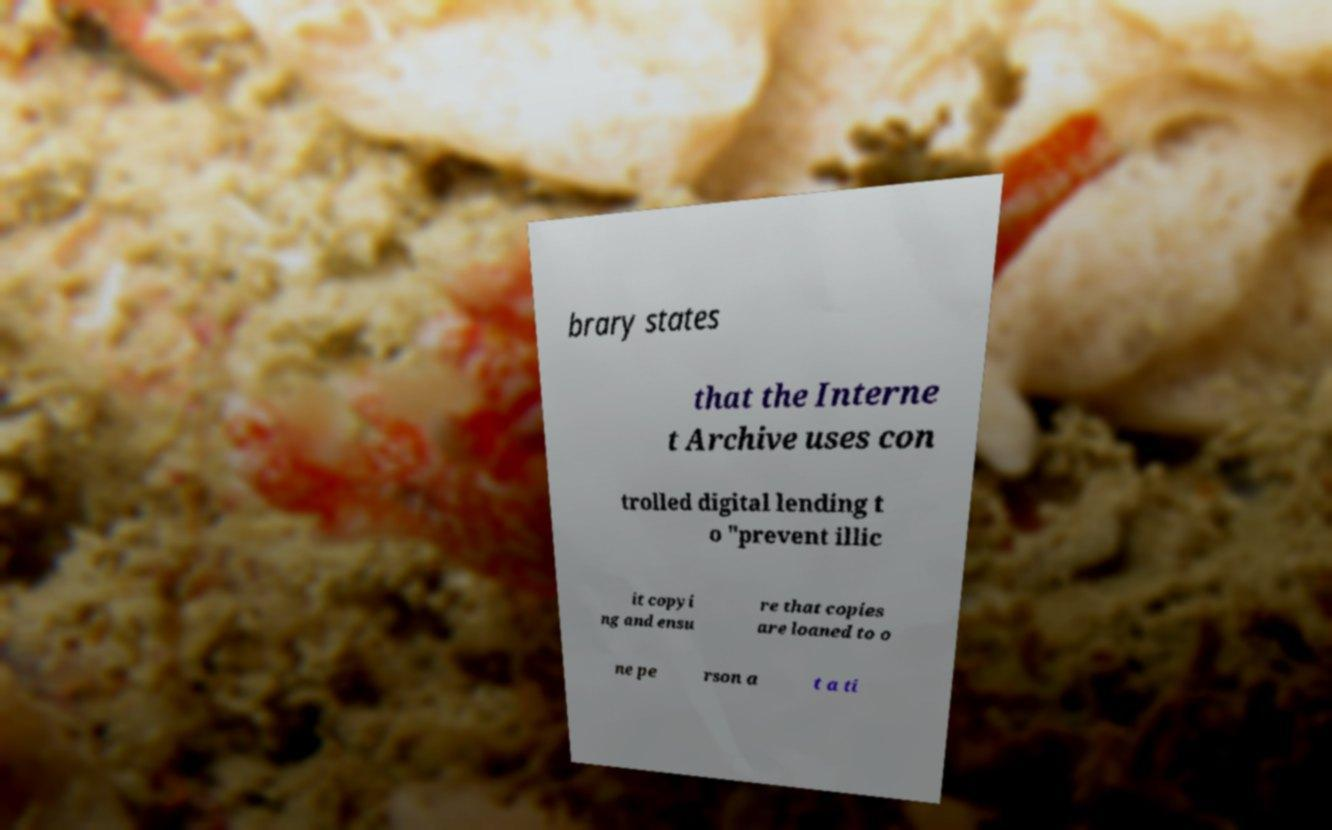What messages or text are displayed in this image? I need them in a readable, typed format. brary states that the Interne t Archive uses con trolled digital lending t o "prevent illic it copyi ng and ensu re that copies are loaned to o ne pe rson a t a ti 